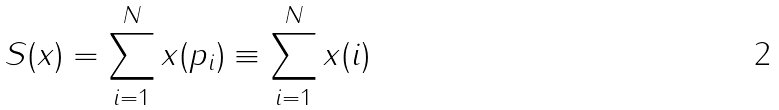<formula> <loc_0><loc_0><loc_500><loc_500>S ( x ) = \sum _ { i = 1 } ^ { N } x ( p _ { i } ) \equiv \sum _ { i = 1 } ^ { N } x ( i )</formula> 